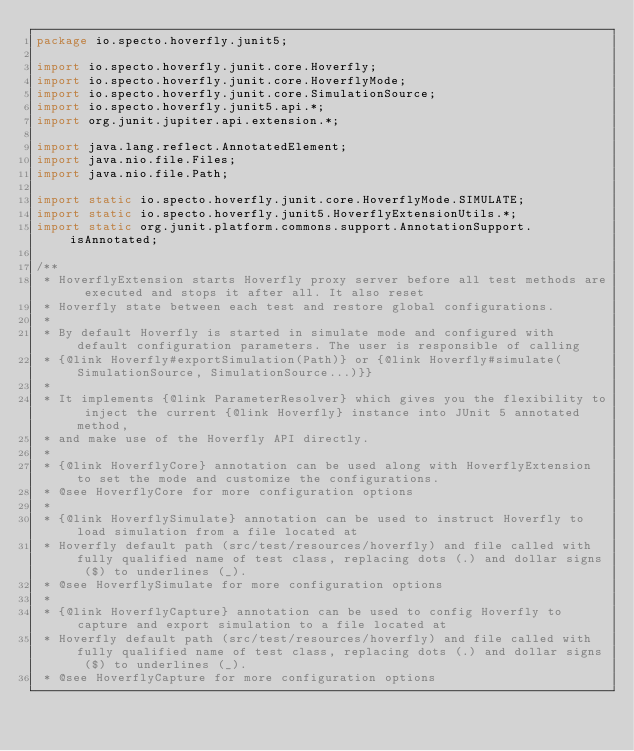<code> <loc_0><loc_0><loc_500><loc_500><_Java_>package io.specto.hoverfly.junit5;

import io.specto.hoverfly.junit.core.Hoverfly;
import io.specto.hoverfly.junit.core.HoverflyMode;
import io.specto.hoverfly.junit.core.SimulationSource;
import io.specto.hoverfly.junit5.api.*;
import org.junit.jupiter.api.extension.*;

import java.lang.reflect.AnnotatedElement;
import java.nio.file.Files;
import java.nio.file.Path;

import static io.specto.hoverfly.junit.core.HoverflyMode.SIMULATE;
import static io.specto.hoverfly.junit5.HoverflyExtensionUtils.*;
import static org.junit.platform.commons.support.AnnotationSupport.isAnnotated;

/**
 * HoverflyExtension starts Hoverfly proxy server before all test methods are executed and stops it after all. It also reset
 * Hoverfly state between each test and restore global configurations.
 *
 * By default Hoverfly is started in simulate mode and configured with default configuration parameters. The user is responsible of calling
 * {@link Hoverfly#exportSimulation(Path)} or {@link Hoverfly#simulate(SimulationSource, SimulationSource...)}}
 *
 * It implements {@link ParameterResolver} which gives you the flexibility to inject the current {@link Hoverfly} instance into JUnit 5 annotated method,
 * and make use of the Hoverfly API directly.
 *
 * {@link HoverflyCore} annotation can be used along with HoverflyExtension to set the mode and customize the configurations.
 * @see HoverflyCore for more configuration options
 *
 * {@link HoverflySimulate} annotation can be used to instruct Hoverfly to load simulation from a file located at
 * Hoverfly default path (src/test/resources/hoverfly) and file called with fully qualified name of test class, replacing dots (.) and dollar signs ($) to underlines (_).
 * @see HoverflySimulate for more configuration options
 *
 * {@link HoverflyCapture} annotation can be used to config Hoverfly to capture and export simulation to a file located at
 * Hoverfly default path (src/test/resources/hoverfly) and file called with fully qualified name of test class, replacing dots (.) and dollar signs ($) to underlines (_).
 * @see HoverflyCapture for more configuration options</code> 